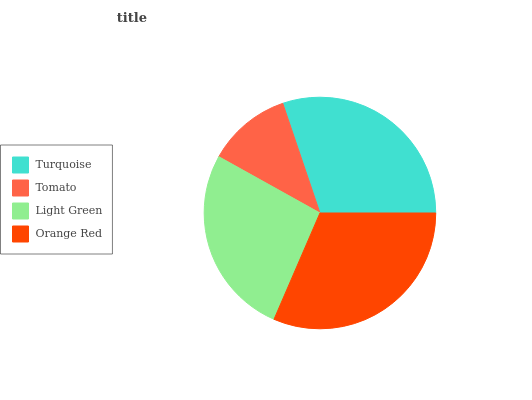Is Tomato the minimum?
Answer yes or no. Yes. Is Orange Red the maximum?
Answer yes or no. Yes. Is Light Green the minimum?
Answer yes or no. No. Is Light Green the maximum?
Answer yes or no. No. Is Light Green greater than Tomato?
Answer yes or no. Yes. Is Tomato less than Light Green?
Answer yes or no. Yes. Is Tomato greater than Light Green?
Answer yes or no. No. Is Light Green less than Tomato?
Answer yes or no. No. Is Turquoise the high median?
Answer yes or no. Yes. Is Light Green the low median?
Answer yes or no. Yes. Is Orange Red the high median?
Answer yes or no. No. Is Turquoise the low median?
Answer yes or no. No. 